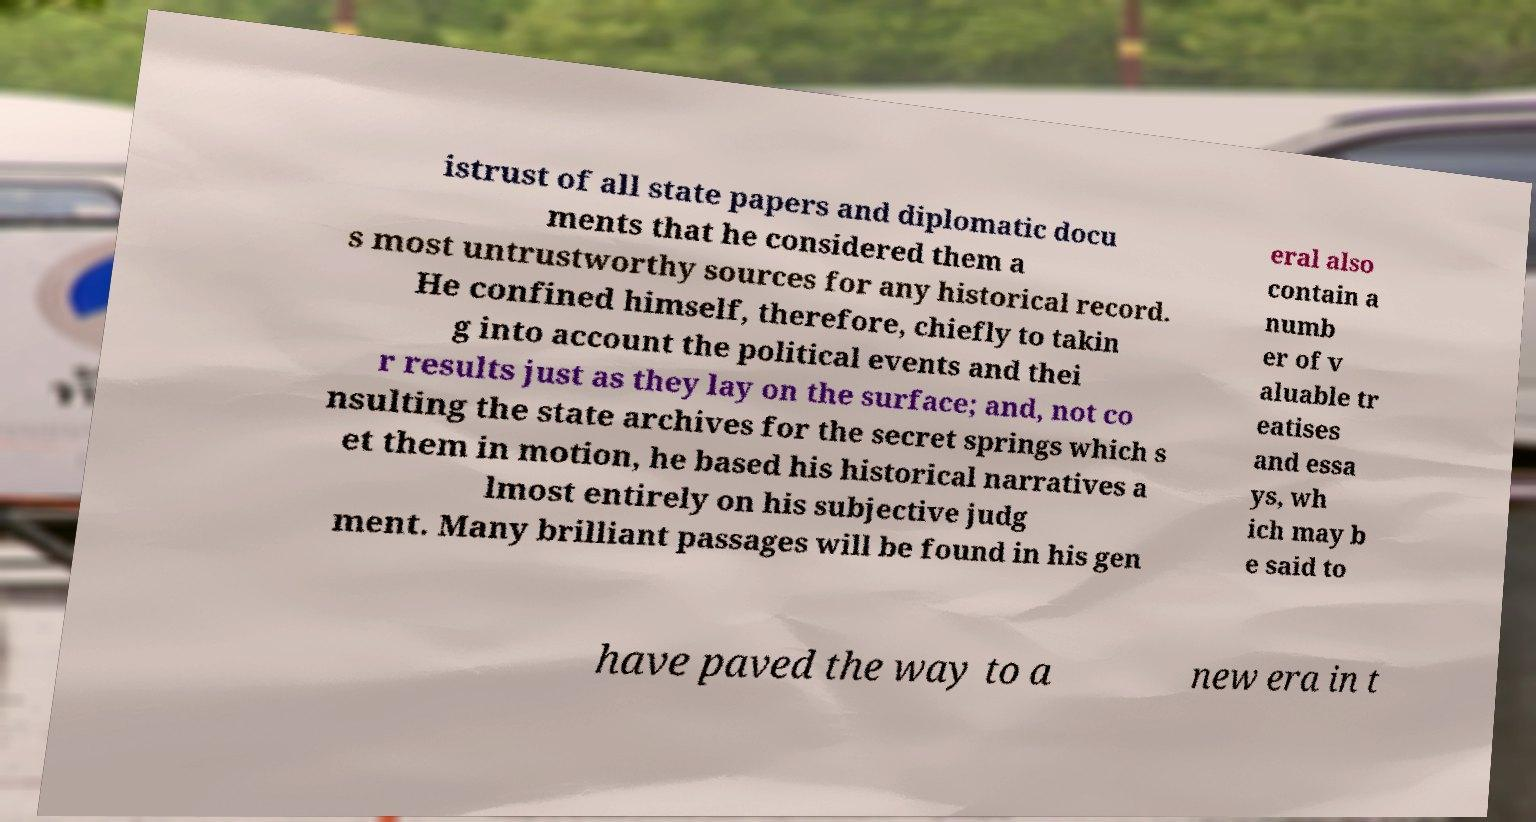Could you assist in decoding the text presented in this image and type it out clearly? istrust of all state papers and diplomatic docu ments that he considered them a s most untrustworthy sources for any historical record. He confined himself, therefore, chiefly to takin g into account the political events and thei r results just as they lay on the surface; and, not co nsulting the state archives for the secret springs which s et them in motion, he based his historical narratives a lmost entirely on his subjective judg ment. Many brilliant passages will be found in his gen eral also contain a numb er of v aluable tr eatises and essa ys, wh ich may b e said to have paved the way to a new era in t 